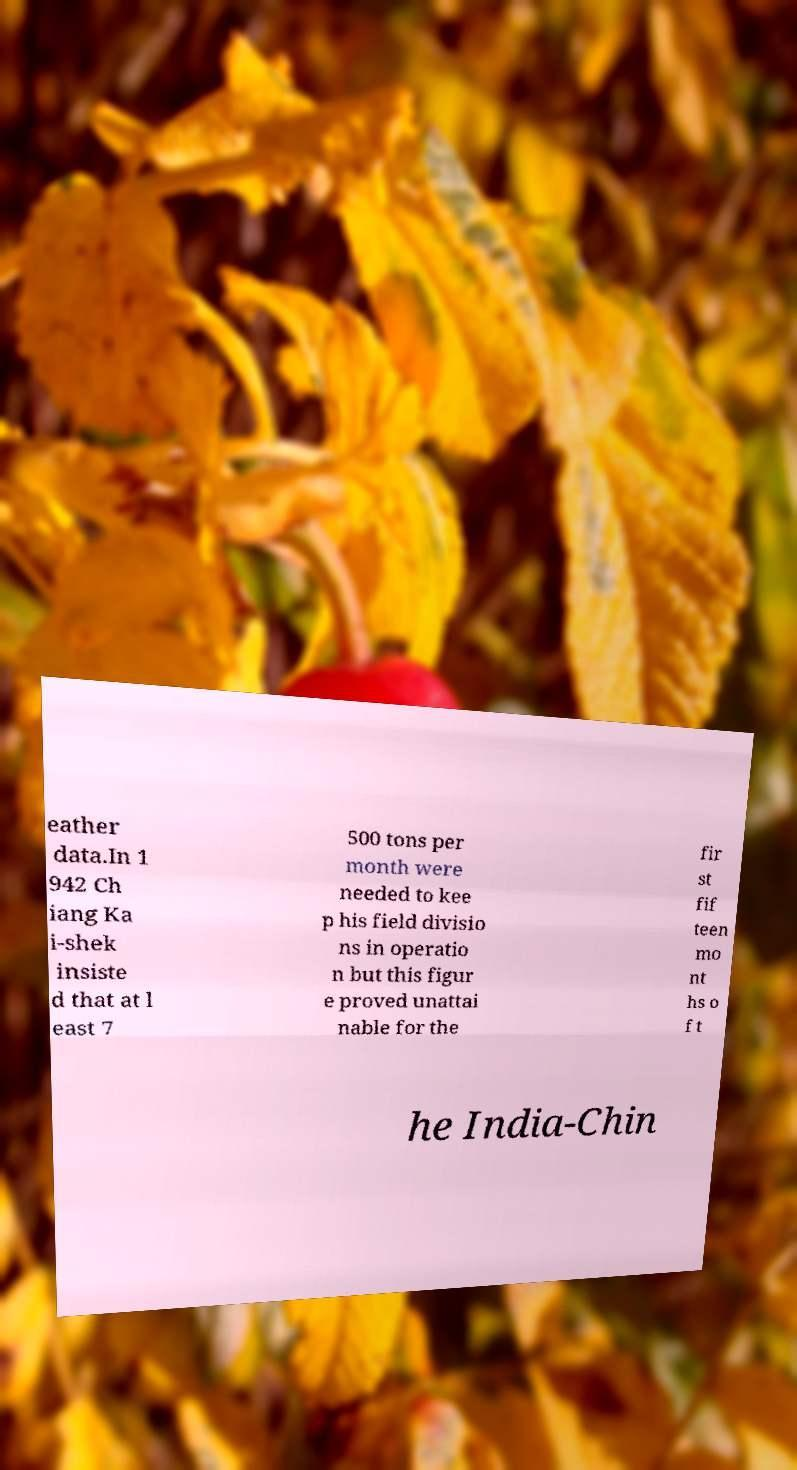Please read and relay the text visible in this image. What does it say? eather data.In 1 942 Ch iang Ka i-shek insiste d that at l east 7 500 tons per month were needed to kee p his field divisio ns in operatio n but this figur e proved unattai nable for the fir st fif teen mo nt hs o f t he India-Chin 